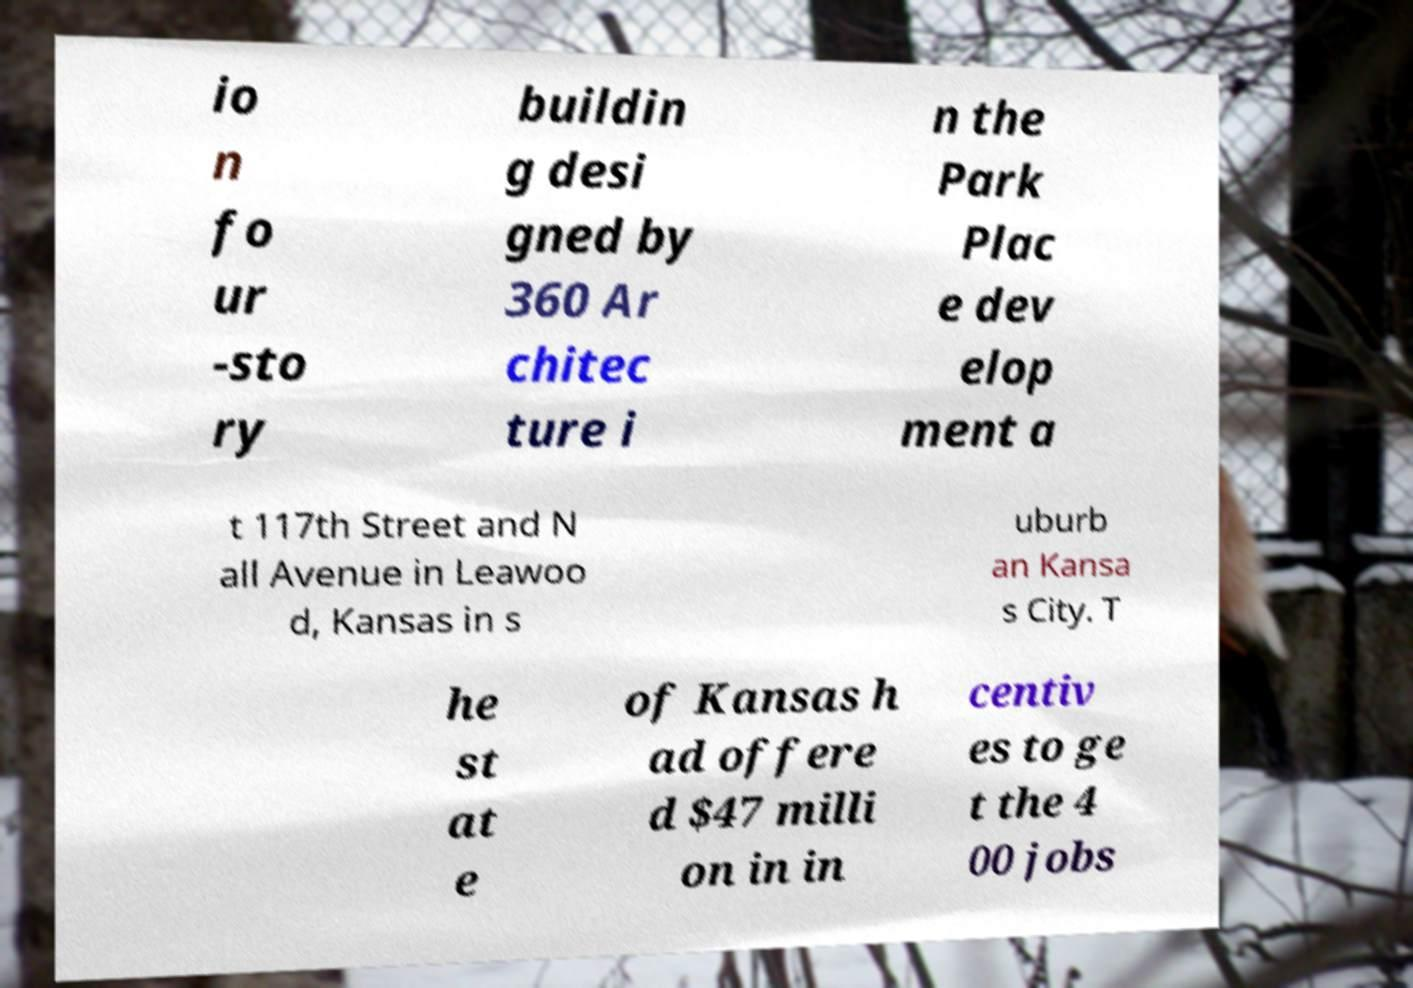Can you accurately transcribe the text from the provided image for me? io n fo ur -sto ry buildin g desi gned by 360 Ar chitec ture i n the Park Plac e dev elop ment a t 117th Street and N all Avenue in Leawoo d, Kansas in s uburb an Kansa s City. T he st at e of Kansas h ad offere d $47 milli on in in centiv es to ge t the 4 00 jobs 